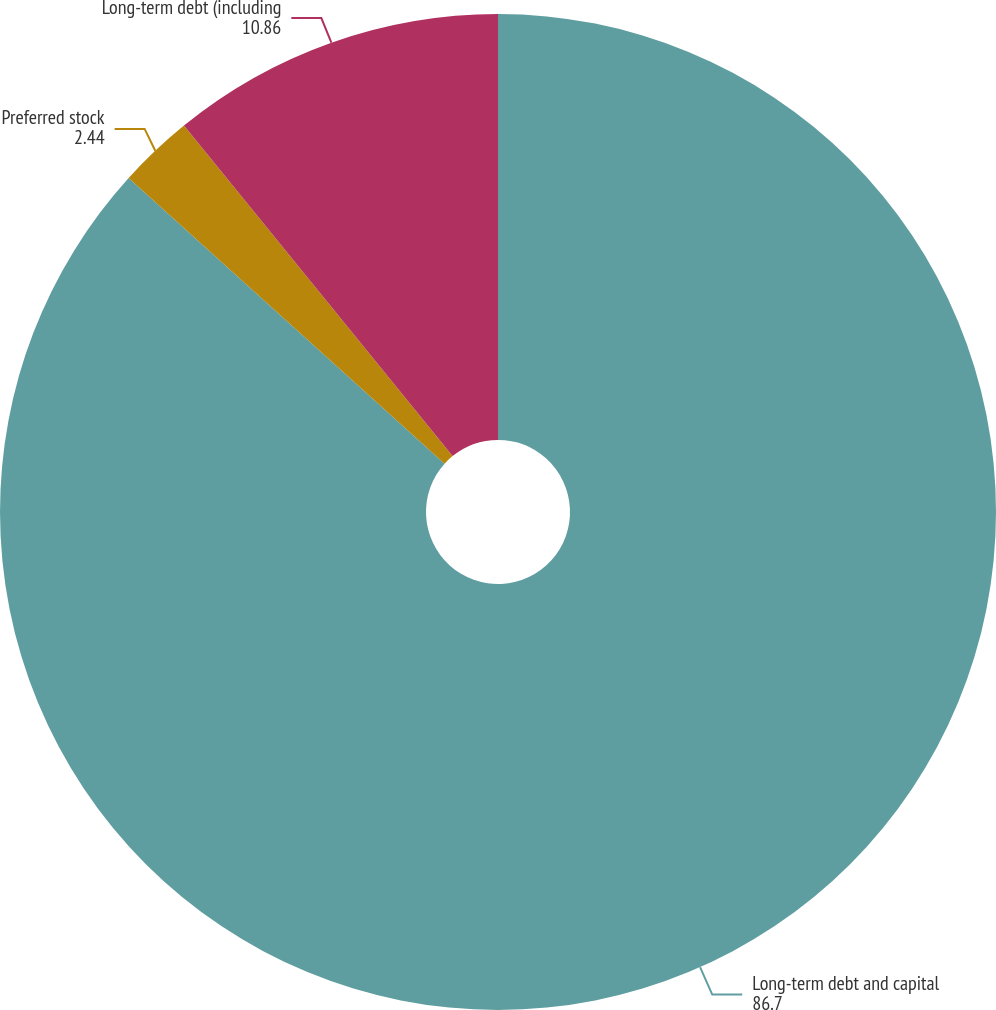Convert chart. <chart><loc_0><loc_0><loc_500><loc_500><pie_chart><fcel>Long-term debt and capital<fcel>Preferred stock<fcel>Long-term debt (including<nl><fcel>86.7%<fcel>2.44%<fcel>10.86%<nl></chart> 